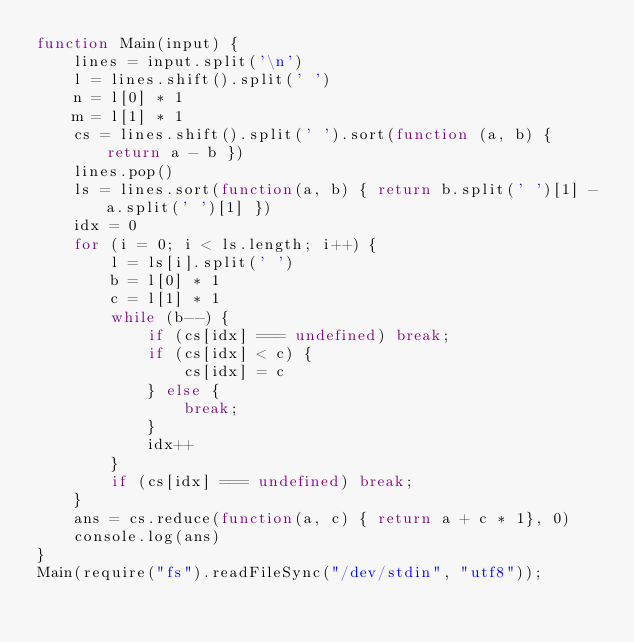<code> <loc_0><loc_0><loc_500><loc_500><_JavaScript_>function Main(input) {
    lines = input.split('\n')
    l = lines.shift().split(' ')
    n = l[0] * 1
    m = l[1] * 1
    cs = lines.shift().split(' ').sort(function (a, b) { return a - b })
    lines.pop()
    ls = lines.sort(function(a, b) { return b.split(' ')[1] - a.split(' ')[1] })
    idx = 0
    for (i = 0; i < ls.length; i++) {
        l = ls[i].split(' ')
        b = l[0] * 1
        c = l[1] * 1
        while (b--) {
            if (cs[idx] === undefined) break;
            if (cs[idx] < c) {
                cs[idx] = c
            } else {
                break;
            }
            idx++
        }
        if (cs[idx] === undefined) break;
    }
    ans = cs.reduce(function(a, c) { return a + c * 1}, 0)
    console.log(ans)
}
Main(require("fs").readFileSync("/dev/stdin", "utf8"));
</code> 